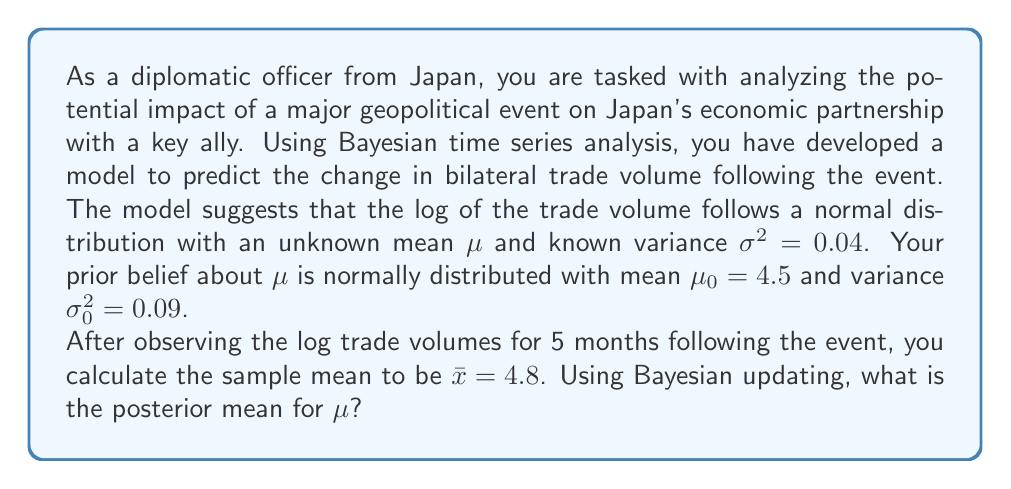Give your solution to this math problem. To solve this problem, we'll use Bayesian updating for a normal distribution with known variance. The steps are as follows:

1) First, recall the formula for the posterior mean in Bayesian updating for a normal distribution with known variance:

   $$\mu_n = \frac{\frac{n}{\sigma^2}\bar{x} + \frac{1}{\sigma_0^2}\mu_0}{\frac{n}{\sigma^2} + \frac{1}{\sigma_0^2}}$$

   Where:
   - μn is the posterior mean
   - n is the number of observations
   - σ² is the known variance of the observations
   - x̄ is the sample mean
   - σ₀² is the prior variance
   - μ₀ is the prior mean

2) We are given:
   - n = 5
   - σ² = 0.04
   - x̄ = 4.8
   - σ₀² = 0.09
   - μ₀ = 4.5

3) Let's substitute these values into the formula:

   $$\mu_n = \frac{\frac{5}{0.04}(4.8) + \frac{1}{0.09}(4.5)}{\frac{5}{0.04} + \frac{1}{0.09}}$$

4) Simplify the numerator:
   $$\mu_n = \frac{125(4.8) + 11.11(4.5)}{125 + 11.11}$$

5) Calculate:
   $$\mu_n = \frac{600 + 50}{136.11} = \frac{650}{136.11}$$

6) Divide:
   $$\mu_n \approx 4.776$$

Therefore, the posterior mean for μ is approximately 4.776.
Answer: 4.776 